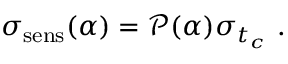Convert formula to latex. <formula><loc_0><loc_0><loc_500><loc_500>\sigma _ { s e n s } ( \alpha ) = \ m a t h s c r { P } ( \alpha ) \sigma _ { t _ { c } } .</formula> 